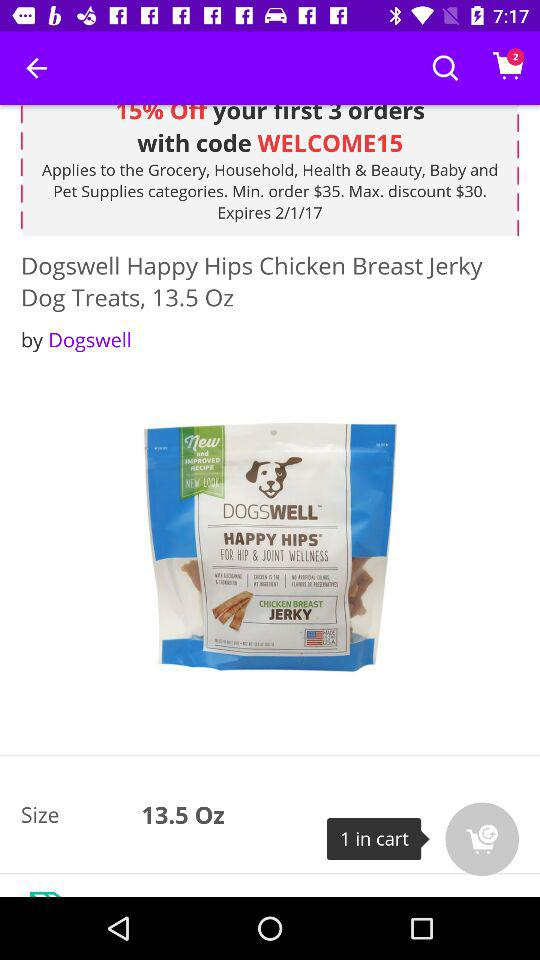What is the code shown on the screen? The code shown on the screen is "WELCOME15". 